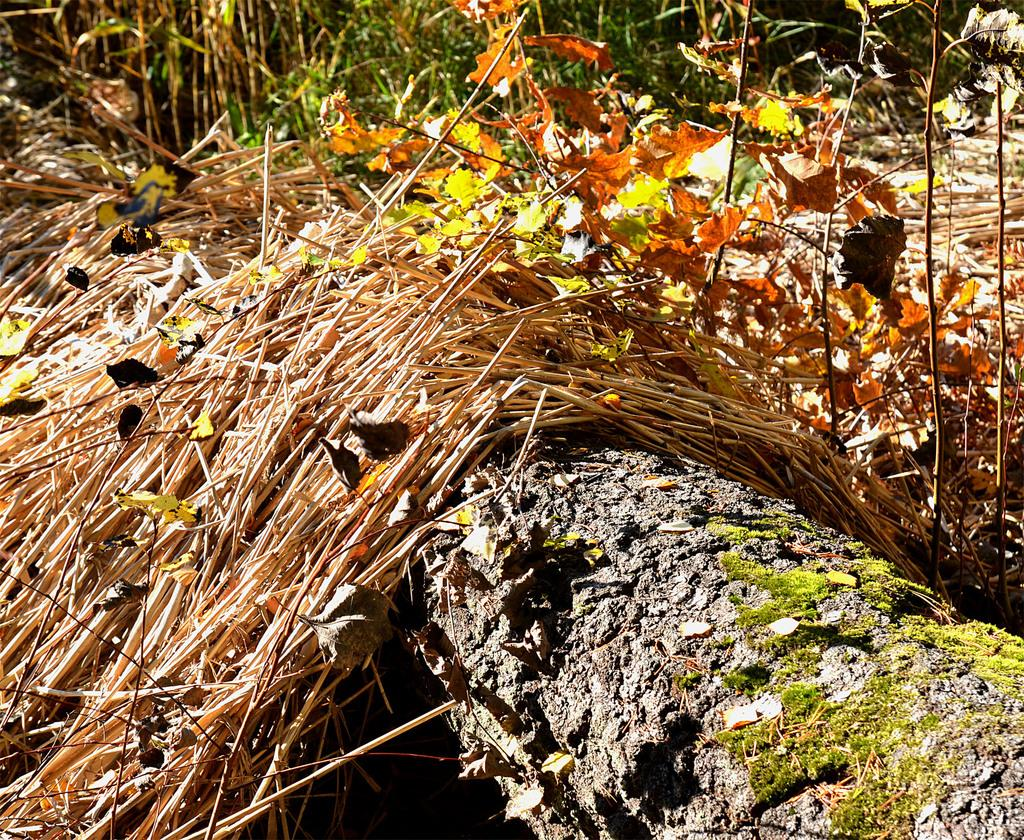What type of living organisms can be seen in the image? Plants can be seen in the image. What other objects are present in the image? There are wooden sticks and an object that looks like a trunk in the image. What type of farmer is responsible for growing the plants in the image? There is no information about a farmer or their responsibility for growing the plants in the image. What type of nation is depicted in the image? The image does not depict a nation; it features plants, wooden sticks, and an object that looks like a trunk. 